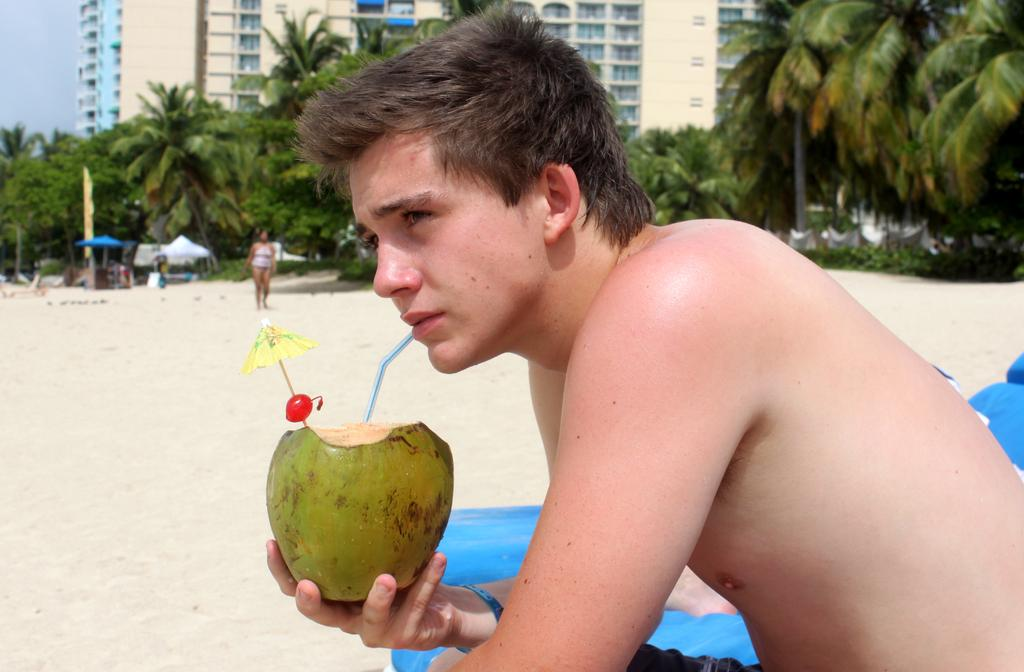What is the man in the image doing? The man is sitting in the image. What is the man holding in the image? The man is holding a coconut. Can you describe the person behind the man? There is a person standing behind the man. What type of vegetation can be seen in the image? There are trees visible in the image. What objects are present for shade or shelter in the image? There are umbrellas and tents in the image. What can be seen in the background of the image? There are buildings and the sky visible in the background. What type of kite is the man flying in the image? There is no kite present in the image; the man is holding a coconut. What dish is the man eating from a plate in the image? There is no plate or dish present in the image. 